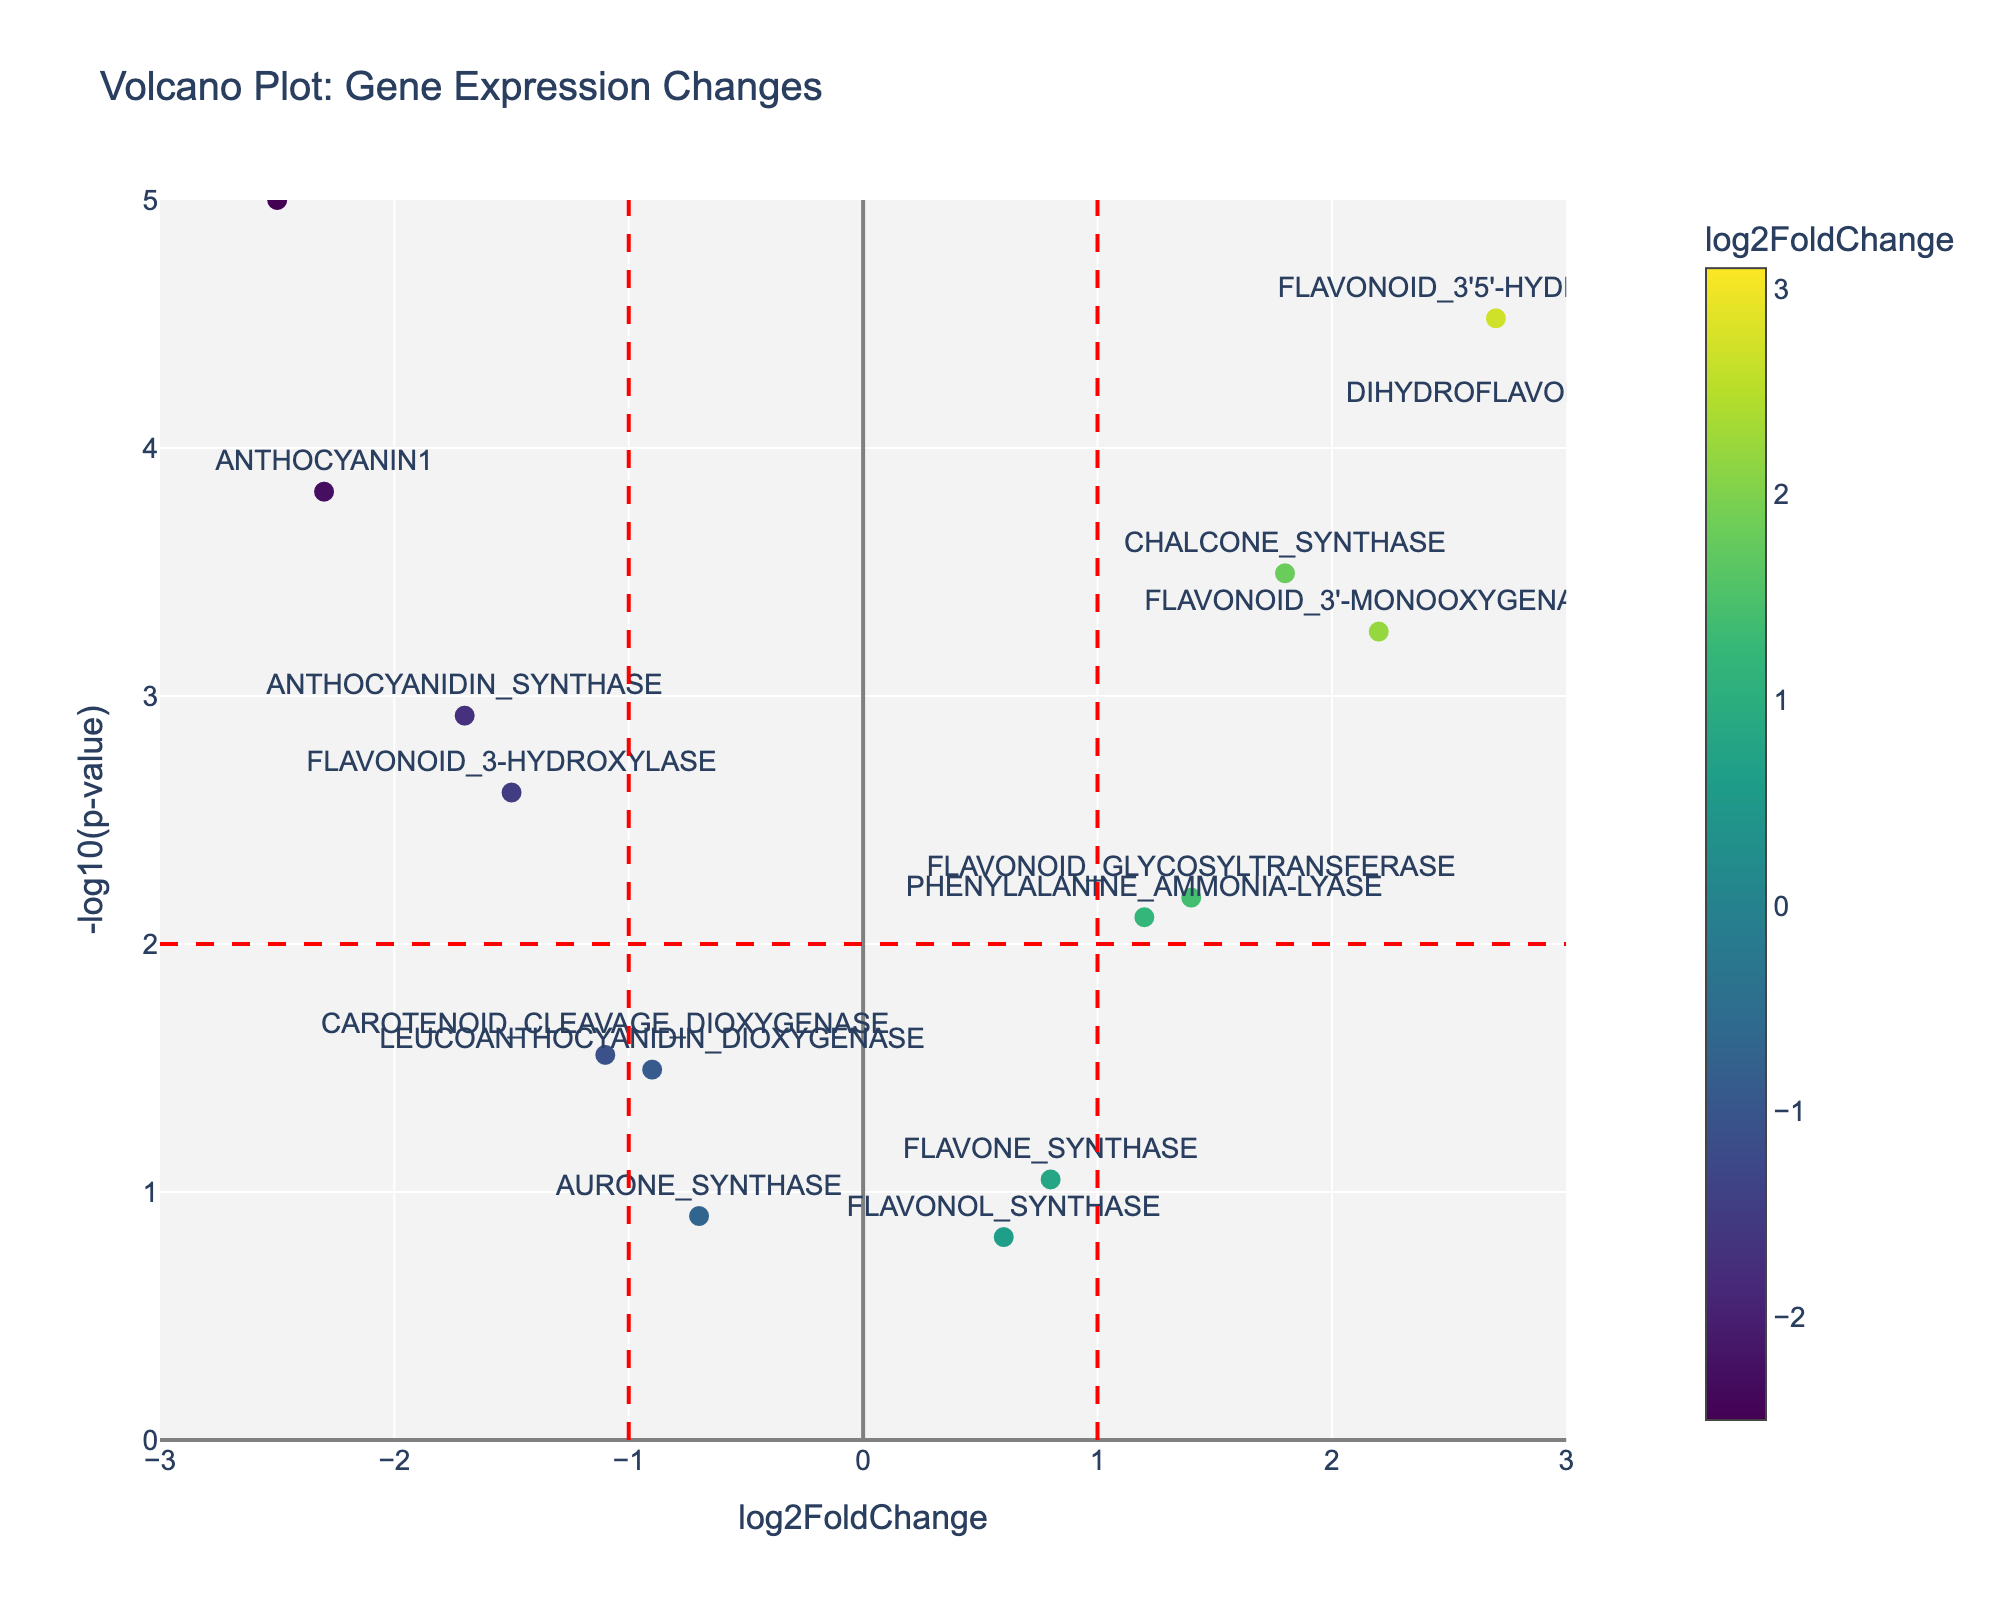What is the title of the figure? The title of the figure is usually placed at the top and serves as a summary of what the figure represents. In this case, the figure's title is clearly written at the top center of the plot.
Answer: Volcano Plot: Gene Expression Changes What is the result for the gene "ANTHOCYANIN1"? To find the result for "ANTHOCYANIN1," look for its label on the plot, then note its position on the x-axis (log2FoldChange) and y-axis (-log10(p-value)). The x-axis value is -2.3, and the y-axis value is around 3.82 (since -log10(0.00015) ≈ 3.82).
Answer: log2FoldChange: -2.3, -log10(p-value): 3.82 Which gene has the highest -log10(p-value)? To determine which gene has the highest -log10(p-value), find the point that is furthest upwards on the y-axis. The gene "ANTHOCYANIN_REDUCTASE" has the highest position on the y-axis, indicating the highest -log10(p-value).
Answer: ANTHOCYANIN_REDUCTASE Which genes are significantly upregulated? Significantly upregulated genes will have a log2FoldChange greater than 1 and a -log10(p-value) greater than 2. The genes "CHALCONE_SYNTHASE," "DIHYDROFLAVONOL_4-REDUCTASE," "FLAVONOID_3'5'-HYDROXYLASE," "FLAVONOID_3'-MONOOXYGENASE," and "FLAVONOID_GLYCOSYLTRANSFERASE" satisfy these conditions.
Answer: CHALCONE_SYNTHASE, DIHYDROFLAVONOL_4-REDUCTASE, FLAVONOID_3'5'-HYDROXYLASE, FLAVONOID_3'-MONOOXYGENASE, FLAVONOID_GLYCOSYLTRANSFERASE Which gene has the lowest log2FoldChange? To find the gene with the lowest log2FoldChange, identify the point furthest to the left on the x-axis. The gene "ANTHOCYANIN_REDUCTASE" has the lowest log2FoldChange at -2.5.
Answer: ANTHOCYANIN_REDUCTASE Which genes have a log2FoldChange between -1 and 1? Examine the points that fall within the vertical dashed lines placed at -1 and 1 on the x-axis. The genes within this range include "LEUCOANTHOCYANIDIN_DIOXYGENASE," "FLAVONOL_SYNTHASE," "FLAVONE_SYNTHASE," and "AURONE_SYNTHASE."
Answer: LEUCOANTHOCYANIDIN_DIOXYGENASE, FLAVONOL_SYNTHASE, FLAVONE_SYNTHASE, AURONE_SYNTHASE Are there any genes with a p-value greater than 0.05? Examine the y-axis values to determine if any points fall below the -log10(p-value)=1.3 line (since -log10(0.05) ≈ 1.3). None of the points fall below this line, indicating that all p-values are less than 0.05.
Answer: No How many genes are downregulated with a log2FoldChange less than -1 but greater than -2? Check the points on the left side of the plot falling between the vertical dashed line at -1 and -2. The genes "ANTHOCYANIN1" and "FLAVONOID_3-HYDROXYLASE" fall within this range.
Answer: 2 Which gene is closest to the log2FoldChange of 0 with a significant p-value? To find the gene closest to a log2FoldChange of 0, look for points near the y-axis. Focus on points with a -log10(p-value) greater than 2 (significant). The gene "PHENYLALANINE_AMMONIA-LYASE" is closest with a log2FoldChange of 1.2 and a -log10(p-value) around 2.10.
Answer: PHENYLALANINE_AMMONIA-LYASE 